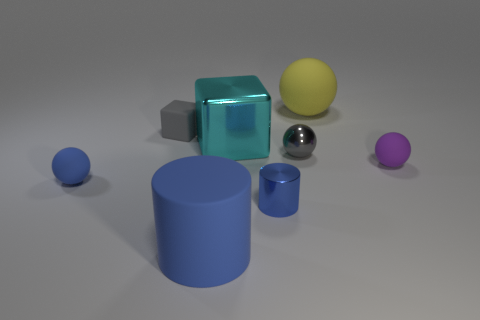There is a small metal object that is the same shape as the big yellow object; what color is it?
Your response must be concise. Gray. What number of matte balls are the same color as the matte cylinder?
Offer a very short reply. 1. Is the number of large cyan cubes that are left of the rubber cylinder greater than the number of red balls?
Offer a terse response. No. There is a tiny ball in front of the small ball on the right side of the large rubber sphere; what color is it?
Make the answer very short. Blue. What number of things are small things on the left side of the tiny purple object or blue objects right of the big cyan object?
Keep it short and to the point. 4. The small cylinder has what color?
Provide a short and direct response. Blue. What number of large blue objects are the same material as the small cube?
Your answer should be very brief. 1. Are there more yellow blocks than matte blocks?
Your answer should be compact. No. How many small blue balls are right of the big matte object that is in front of the purple rubber ball?
Offer a terse response. 0. How many things are either matte things behind the tiny gray shiny thing or tiny things?
Give a very brief answer. 6. 